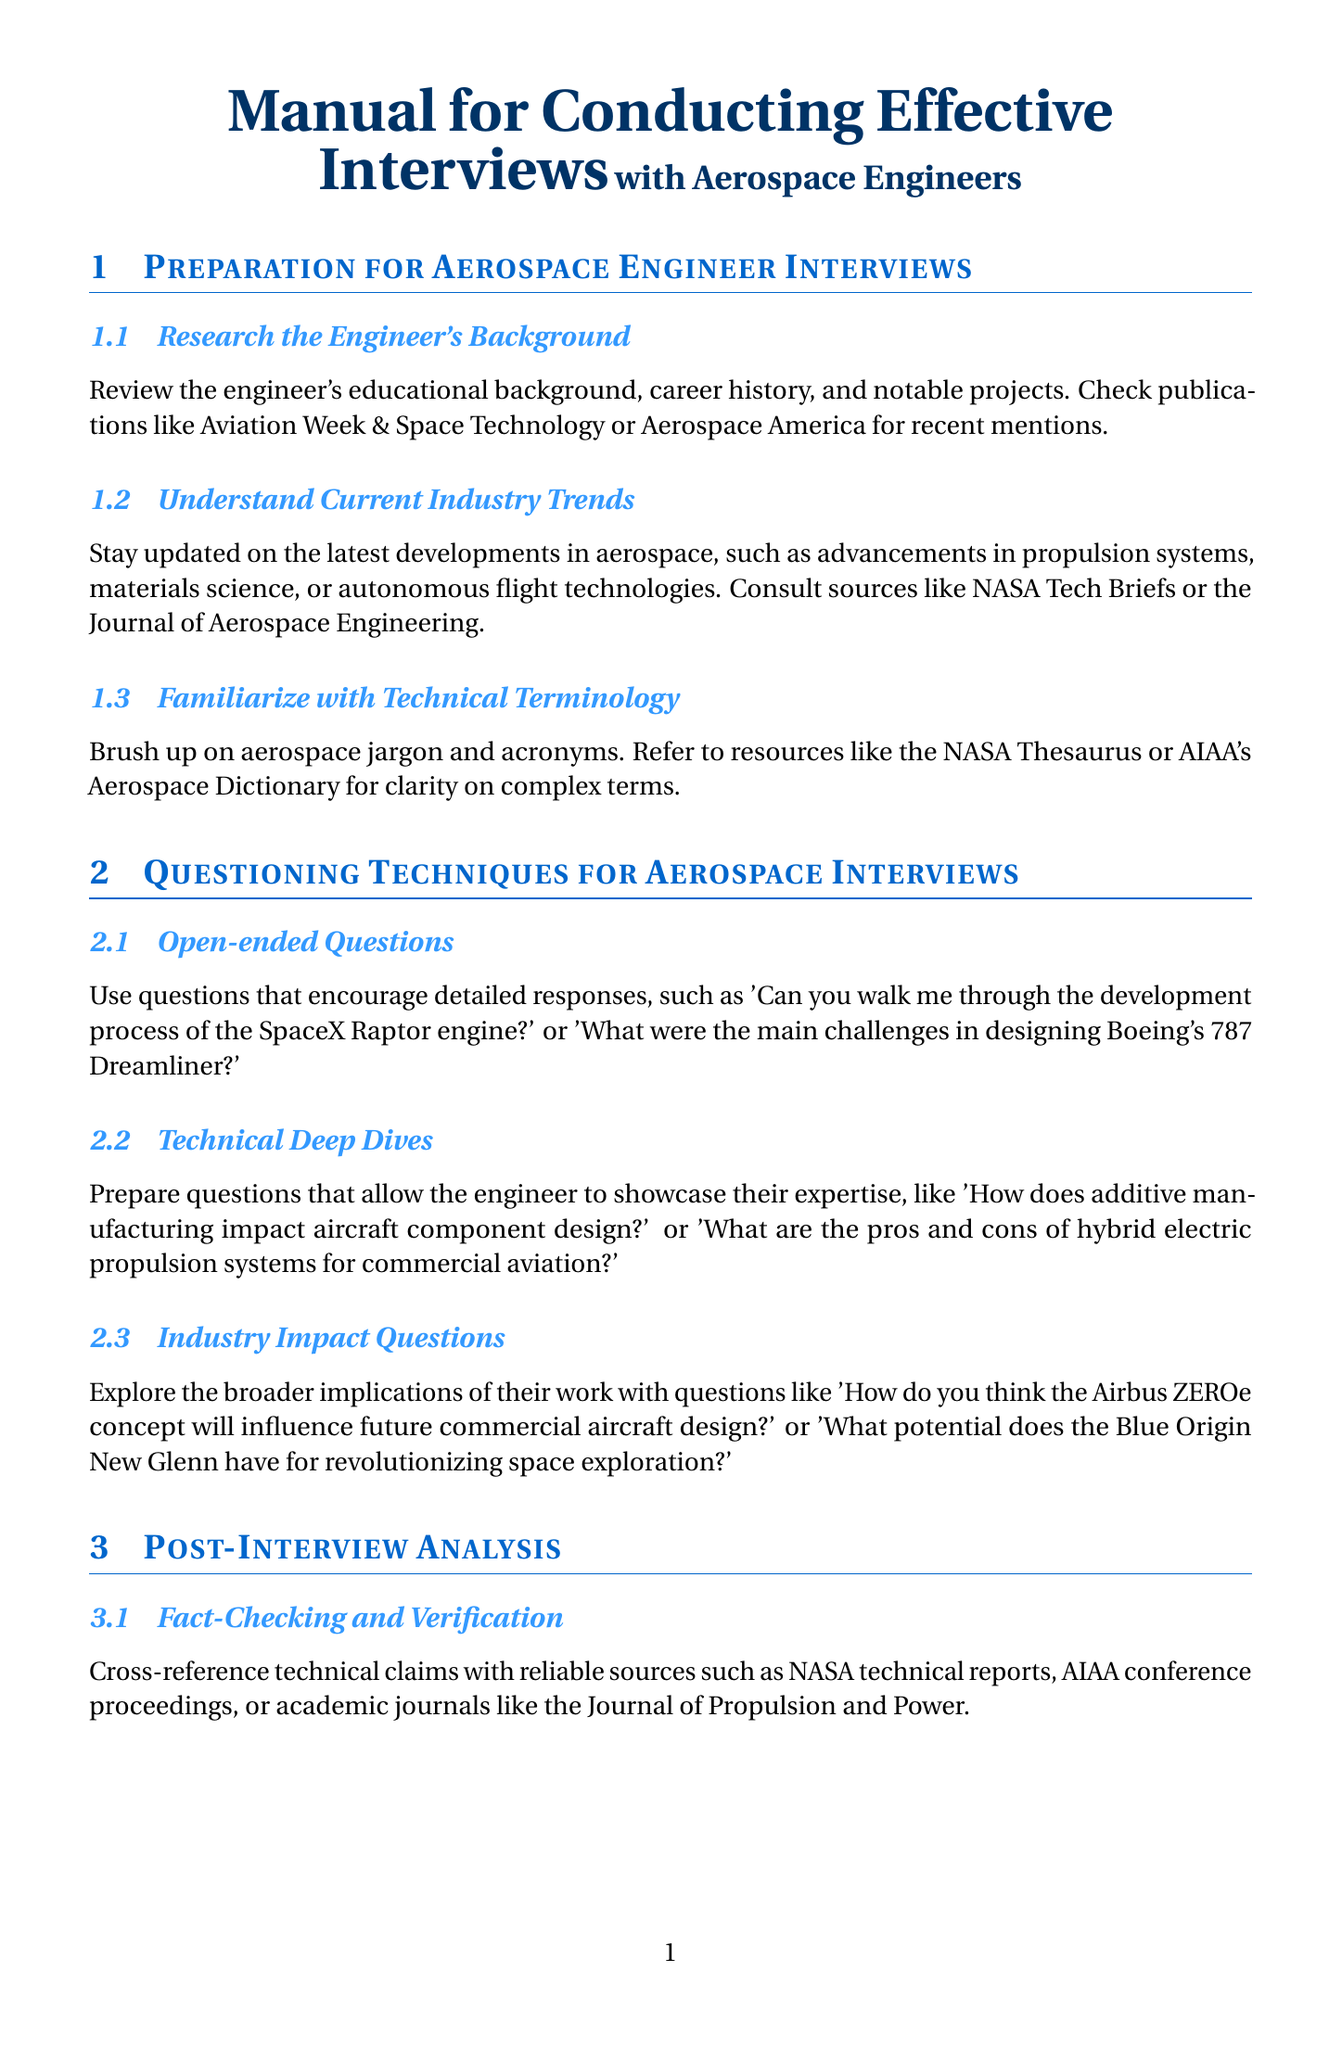What is the title of the manual? The title of the manual is specified in the document and clearly states the focus on conducting interviews with aerospace engineers.
Answer: Manual for Conducting Effective Interviews with Aerospace Engineers What publication is recommended for checking the engineer's notable projects? The document suggests specific publications to review recent mentions of engineers and their projects, including Aviation Week & Space Technology.
Answer: Aviation Week & Space Technology What type of questions encourages detailed responses in interviews? The document describes specific questioning techniques, highlighting that open-ended questions allow for more elaborate answers.
Answer: Open-ended Questions What is one source to consult for understanding current industry trends? The manual points to certain sources that provide up-to-date information on industry trends in aerospace.
Answer: NASA Tech Briefs What should you send after the interview as a follow-up? The document emphasizes the importance of communication post-interview, recommending a specific action to maintain relationships.
Answer: Thank-you note What is the purpose of fact-checking and verification in post-interview analysis? The manual describes the necessity of cross-referencing technical claims made by the interviewee with trusted sources.
Answer: Accuracy How can you deepen your network with aerospace engineers according to the manual? The document provides a strategy for building long-term relationships which includes participation in specific types of events.
Answer: Attend industry events What are two types of questions suggested for technical deep dives? The document lists specific question strategies that enable experts to showcase their knowledge, indicating how technical issues can be examined.
Answer: Additive manufacturing impact and hybrid electric propulsion What is the ultimate goal of identifying key takeaways from an interview? The manual identifies a crucial outcome of interviews, which encompasses the impactful points that hold significance for readers.
Answer: Groundbreaking innovations 